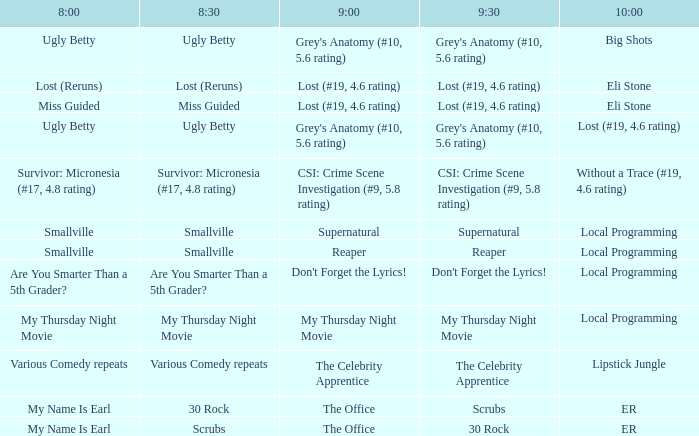What is at 10:00 when at 9:00 it is reaper? Local Programming. 